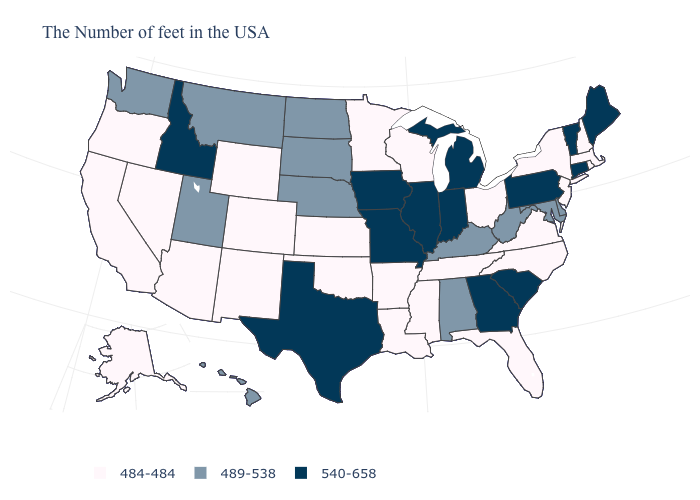Name the states that have a value in the range 489-538?
Be succinct. Delaware, Maryland, West Virginia, Kentucky, Alabama, Nebraska, South Dakota, North Dakota, Utah, Montana, Washington, Hawaii. How many symbols are there in the legend?
Short answer required. 3. Name the states that have a value in the range 489-538?
Short answer required. Delaware, Maryland, West Virginia, Kentucky, Alabama, Nebraska, South Dakota, North Dakota, Utah, Montana, Washington, Hawaii. Name the states that have a value in the range 484-484?
Give a very brief answer. Massachusetts, Rhode Island, New Hampshire, New York, New Jersey, Virginia, North Carolina, Ohio, Florida, Tennessee, Wisconsin, Mississippi, Louisiana, Arkansas, Minnesota, Kansas, Oklahoma, Wyoming, Colorado, New Mexico, Arizona, Nevada, California, Oregon, Alaska. What is the value of South Carolina?
Concise answer only. 540-658. Which states have the highest value in the USA?
Keep it brief. Maine, Vermont, Connecticut, Pennsylvania, South Carolina, Georgia, Michigan, Indiana, Illinois, Missouri, Iowa, Texas, Idaho. What is the lowest value in states that border New York?
Write a very short answer. 484-484. What is the value of Maryland?
Concise answer only. 489-538. Among the states that border Ohio , which have the lowest value?
Answer briefly. West Virginia, Kentucky. Among the states that border Texas , which have the lowest value?
Quick response, please. Louisiana, Arkansas, Oklahoma, New Mexico. Name the states that have a value in the range 540-658?
Quick response, please. Maine, Vermont, Connecticut, Pennsylvania, South Carolina, Georgia, Michigan, Indiana, Illinois, Missouri, Iowa, Texas, Idaho. Which states have the highest value in the USA?
Concise answer only. Maine, Vermont, Connecticut, Pennsylvania, South Carolina, Georgia, Michigan, Indiana, Illinois, Missouri, Iowa, Texas, Idaho. Among the states that border Utah , which have the highest value?
Keep it brief. Idaho. What is the value of Mississippi?
Be succinct. 484-484. What is the highest value in the West ?
Write a very short answer. 540-658. 